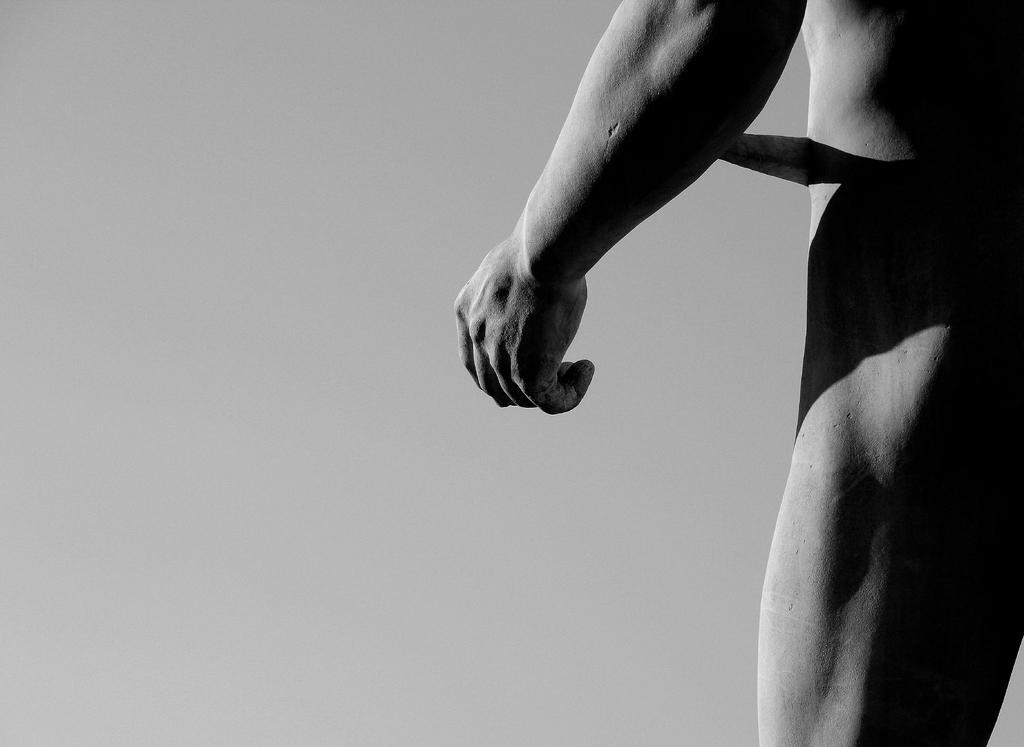Can you describe this image briefly? On the right side we can see a part of a person. In the back there is a wall. This is a black and white image. 